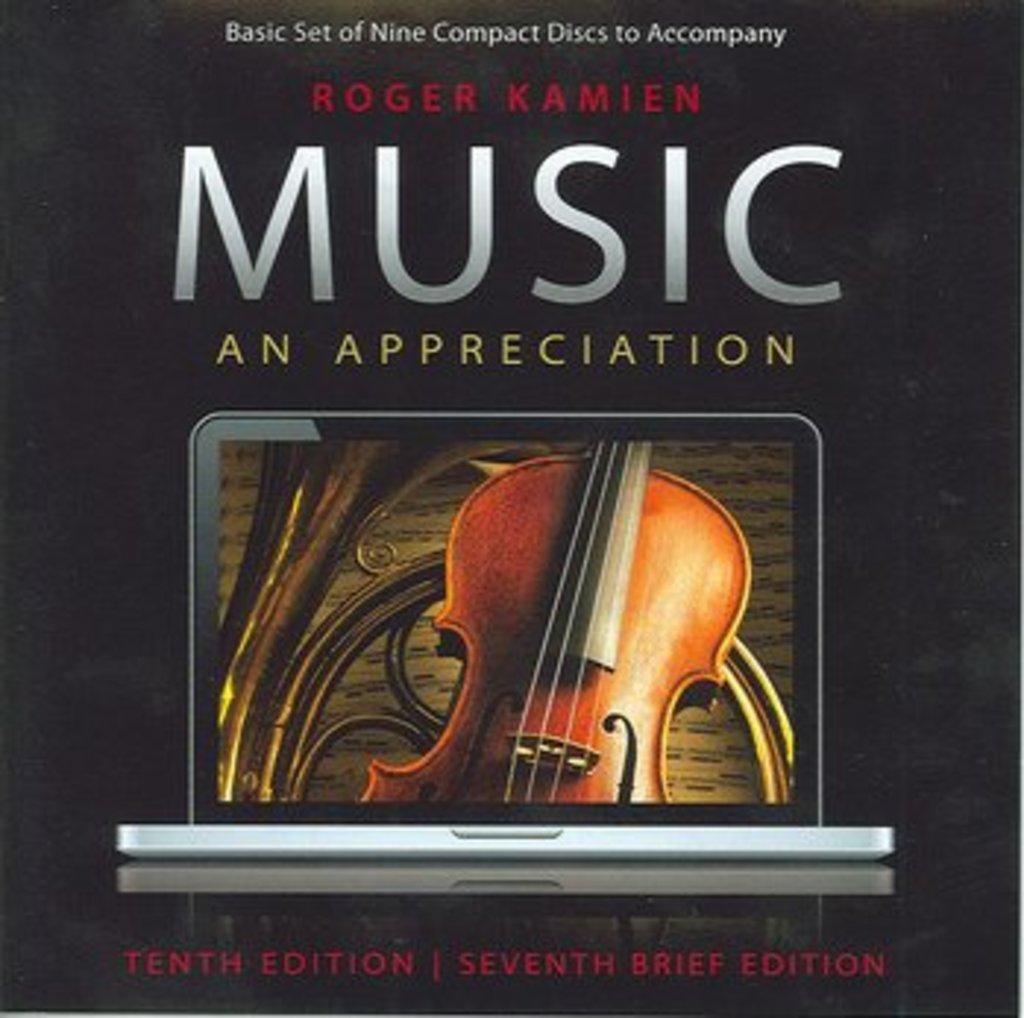Who is the author of the book?
Your response must be concise. Roger kamien. 